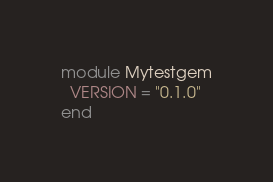Convert code to text. <code><loc_0><loc_0><loc_500><loc_500><_Ruby_>module Mytestgem
  VERSION = "0.1.0"
end
</code> 